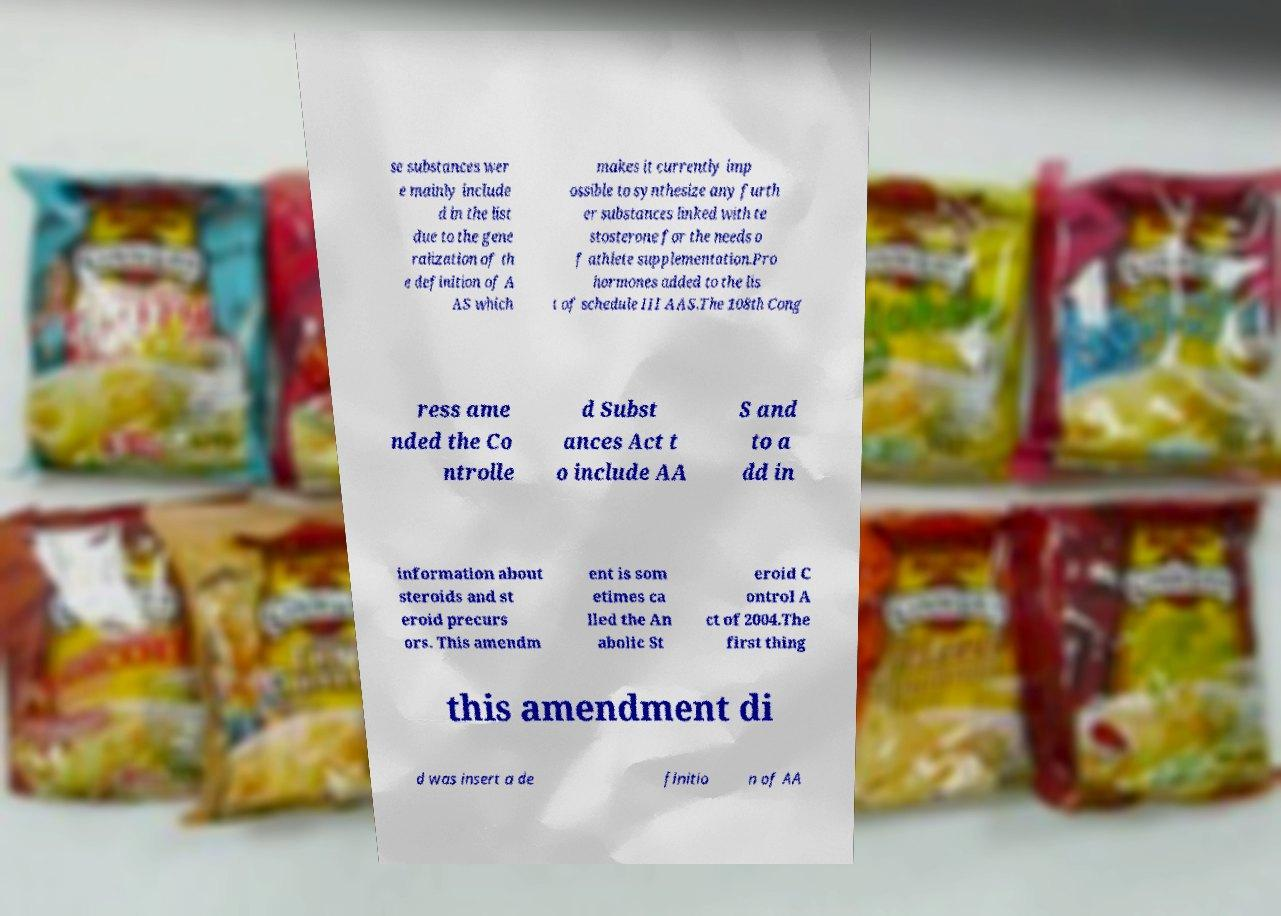Please read and relay the text visible in this image. What does it say? se substances wer e mainly include d in the list due to the gene ralization of th e definition of A AS which makes it currently imp ossible to synthesize any furth er substances linked with te stosterone for the needs o f athlete supplementation.Pro hormones added to the lis t of schedule III AAS.The 108th Cong ress ame nded the Co ntrolle d Subst ances Act t o include AA S and to a dd in information about steroids and st eroid precurs ors. This amendm ent is som etimes ca lled the An abolic St eroid C ontrol A ct of 2004.The first thing this amendment di d was insert a de finitio n of AA 